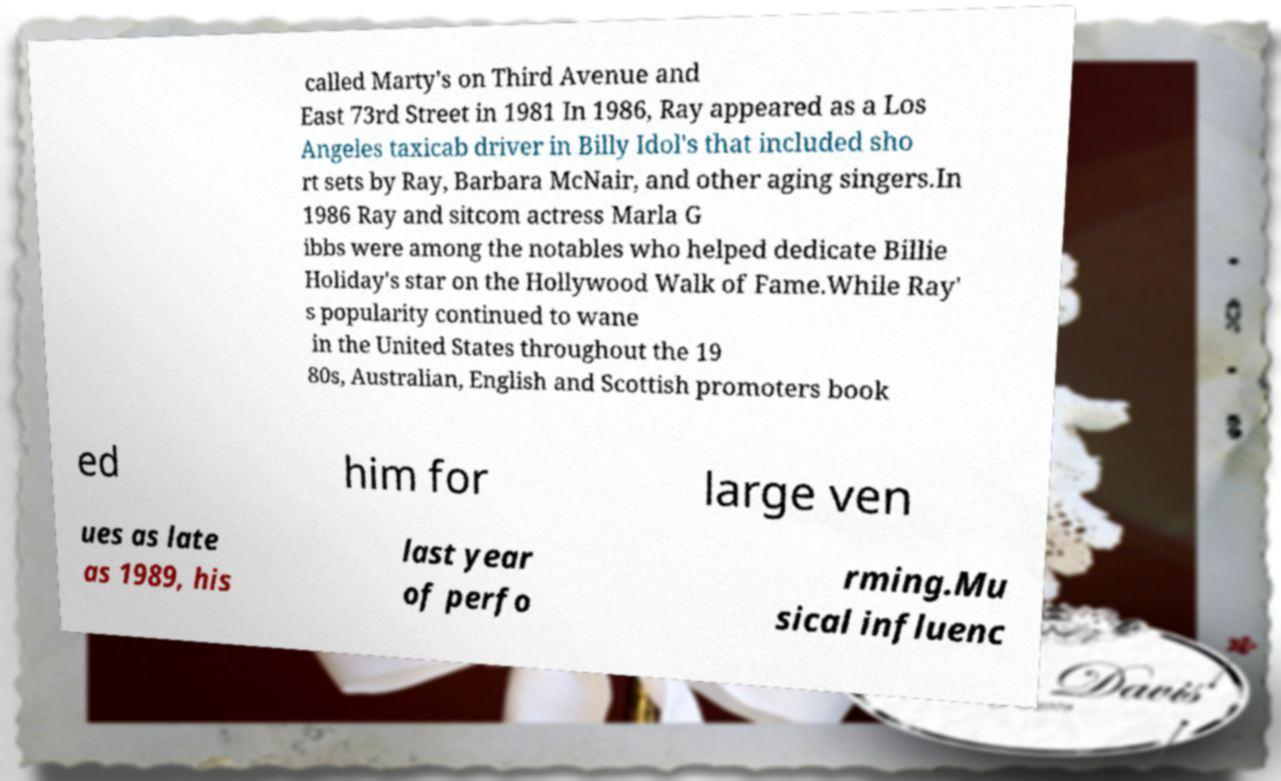For documentation purposes, I need the text within this image transcribed. Could you provide that? called Marty's on Third Avenue and East 73rd Street in 1981 In 1986, Ray appeared as a Los Angeles taxicab driver in Billy Idol's that included sho rt sets by Ray, Barbara McNair, and other aging singers.In 1986 Ray and sitcom actress Marla G ibbs were among the notables who helped dedicate Billie Holiday's star on the Hollywood Walk of Fame.While Ray' s popularity continued to wane in the United States throughout the 19 80s, Australian, English and Scottish promoters book ed him for large ven ues as late as 1989, his last year of perfo rming.Mu sical influenc 